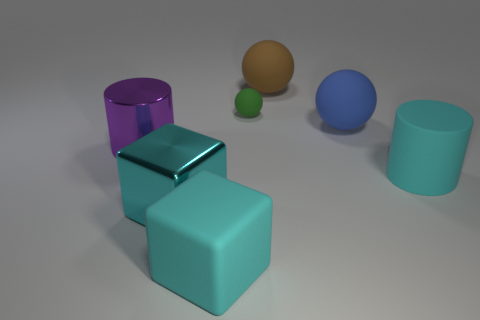What is the size of the rubber cylinder that is the same color as the large metallic block?
Keep it short and to the point. Large. How many purple things are either balls or metal cylinders?
Offer a very short reply. 1. What number of other things are the same shape as the big brown thing?
Provide a short and direct response. 2. There is a cyan object that is behind the cyan matte block and to the left of the green object; what shape is it?
Your answer should be very brief. Cube. Are there any matte cylinders behind the big cyan matte cylinder?
Give a very brief answer. No. The other blue rubber object that is the same shape as the tiny object is what size?
Keep it short and to the point. Large. Is there anything else that has the same size as the blue object?
Your answer should be compact. Yes. Is the shape of the small green matte thing the same as the large purple metallic object?
Make the answer very short. No. There is a cyan rubber object that is behind the shiny cube on the left side of the green rubber thing; how big is it?
Ensure brevity in your answer.  Large. What color is the other rubber object that is the same shape as the large purple object?
Your answer should be very brief. Cyan. 